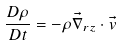Convert formula to latex. <formula><loc_0><loc_0><loc_500><loc_500>\frac { D \rho } { D t } = - \rho \vec { \nabla } _ { r z } \cdot \vec { v }</formula> 